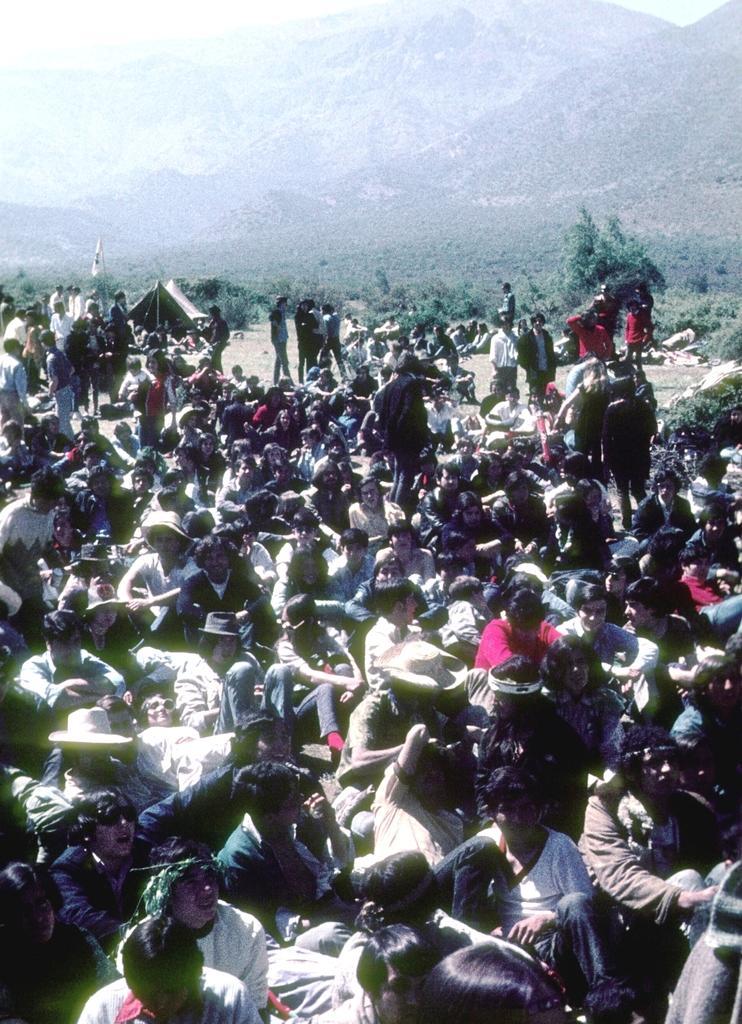In one or two sentences, can you explain what this image depicts? In this image we can see a group of people, some are sitting and some of them are standing, there is a tent, hills, at the top we can see the sky. 